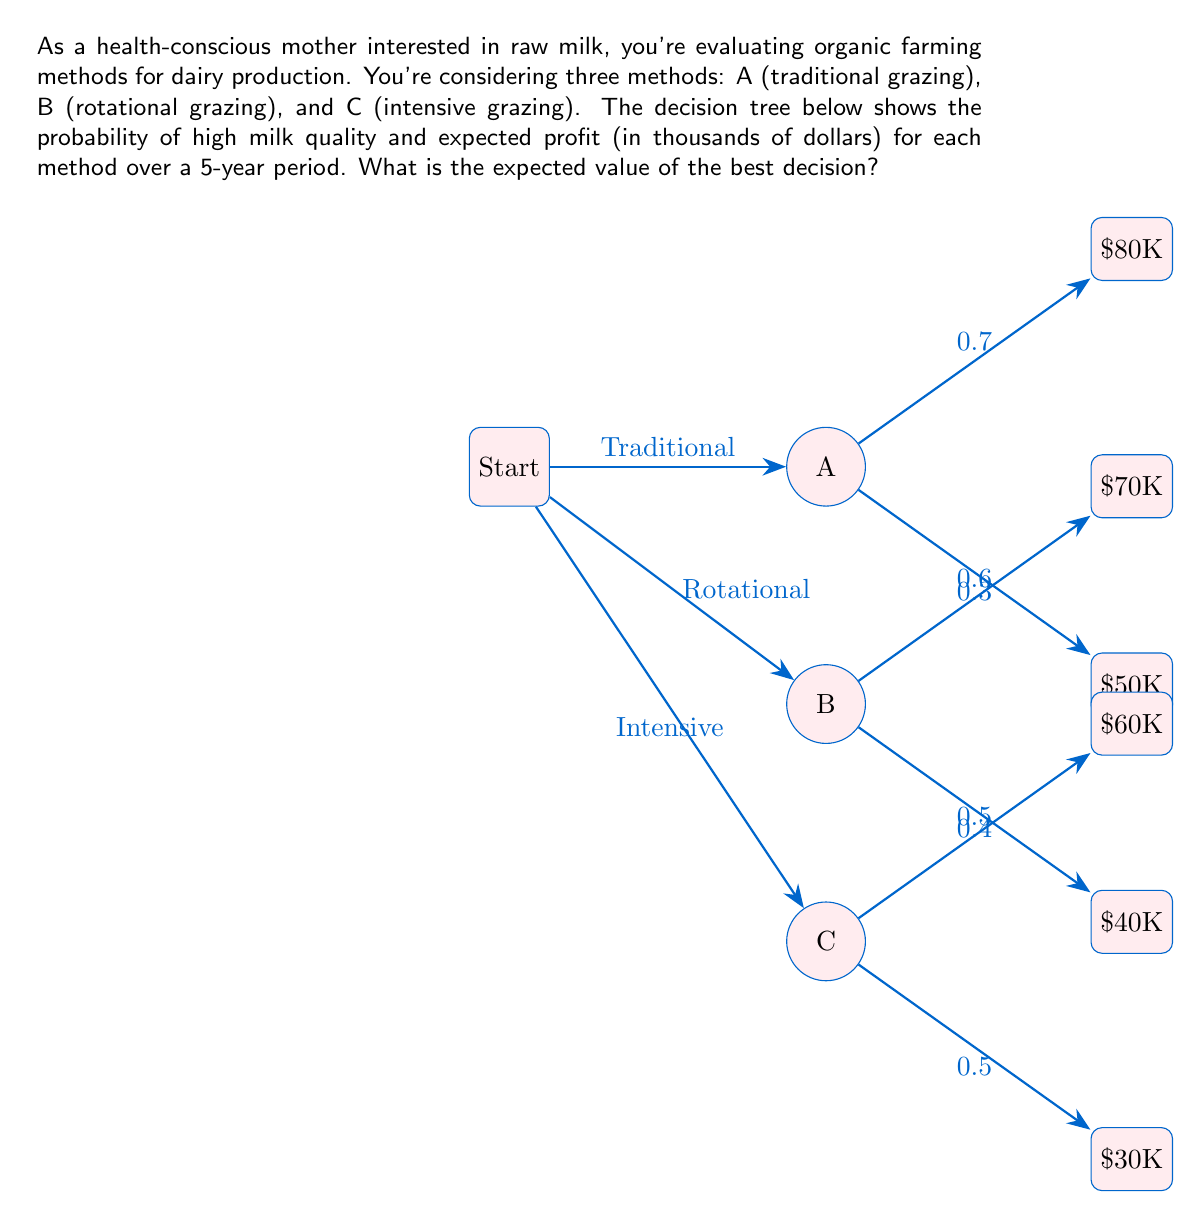Can you answer this question? Let's calculate the expected value for each method:

1. Method A (Traditional Grazing):
   $$EV(A) = 0.7 \times 80 + 0.3 \times 50 = 56 + 15 = 71$$

2. Method B (Rotational Grazing):
   $$EV(B) = 0.6 \times 70 + 0.4 \times 40 = 42 + 16 = 58$$

3. Method C (Intensive Grazing):
   $$EV(C) = 0.5 \times 60 + 0.5 \times 30 = 30 + 15 = 45$$

The best decision is the one with the highest expected value. In this case, Method A has the highest expected value of $71,000 over the 5-year period.

Therefore, the expected value of the best decision is $71,000.
Answer: $71,000 